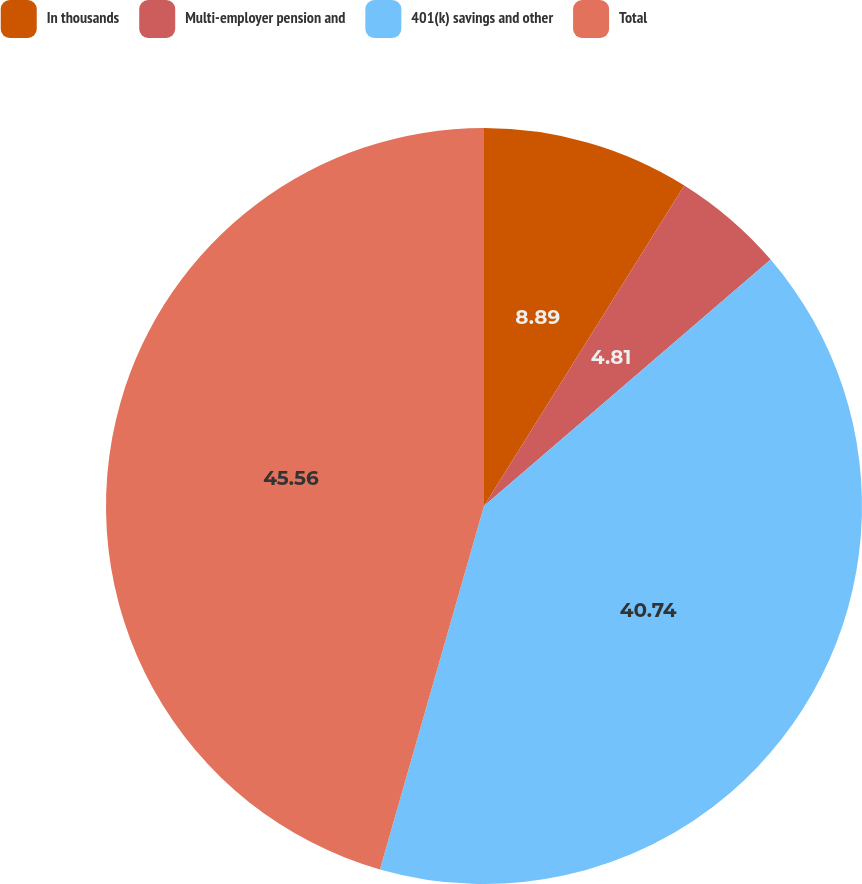<chart> <loc_0><loc_0><loc_500><loc_500><pie_chart><fcel>In thousands<fcel>Multi-employer pension and<fcel>401(k) savings and other<fcel>Total<nl><fcel>8.89%<fcel>4.81%<fcel>40.74%<fcel>45.56%<nl></chart> 